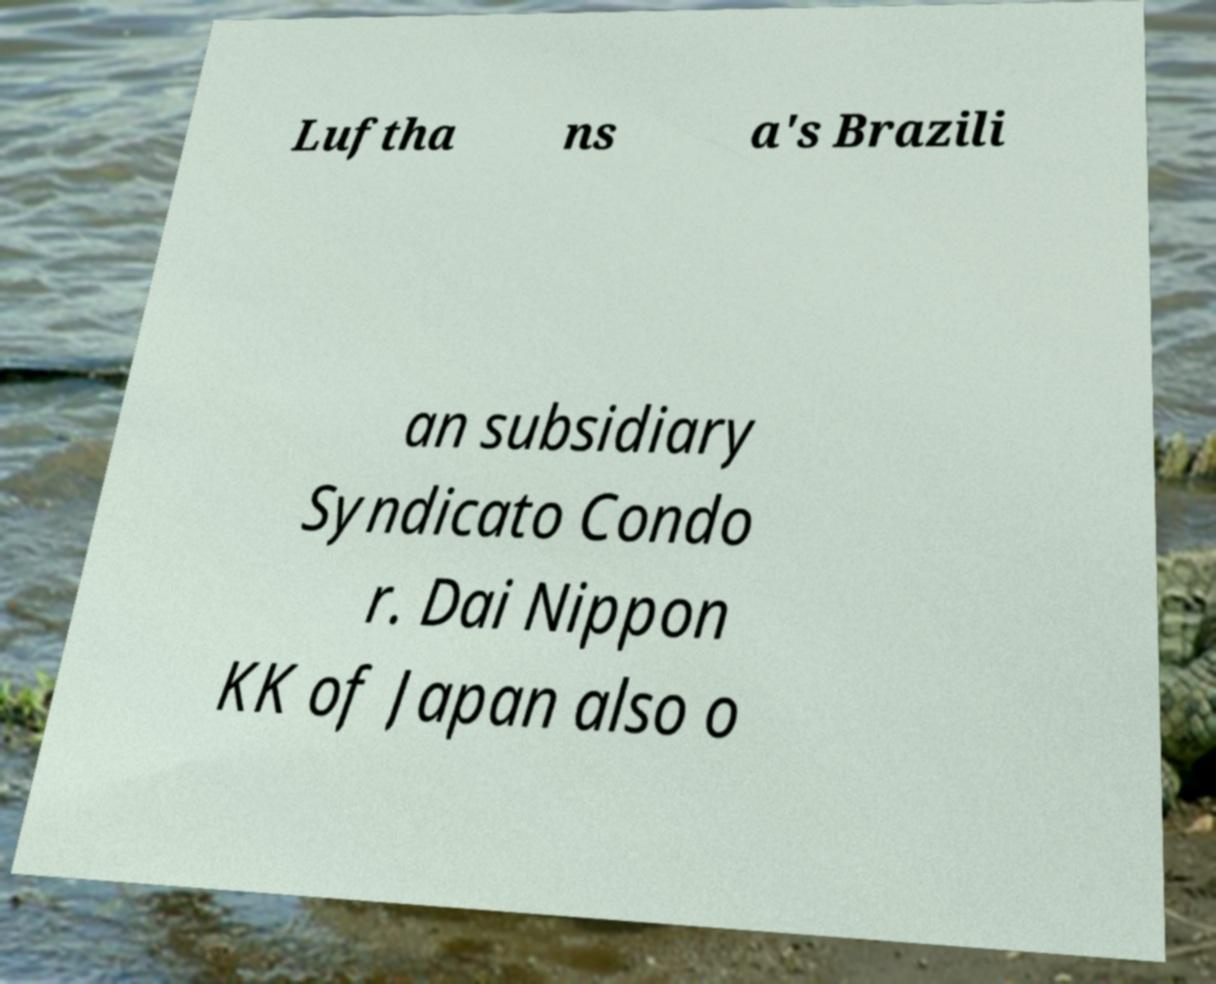Can you read and provide the text displayed in the image?This photo seems to have some interesting text. Can you extract and type it out for me? Luftha ns a's Brazili an subsidiary Syndicato Condo r. Dai Nippon KK of Japan also o 